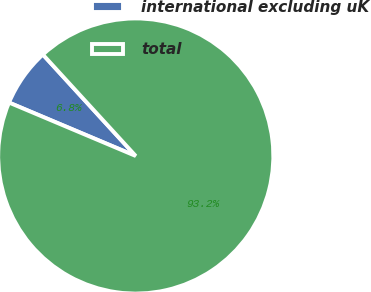<chart> <loc_0><loc_0><loc_500><loc_500><pie_chart><fcel>international excluding uK<fcel>total<nl><fcel>6.85%<fcel>93.15%<nl></chart> 